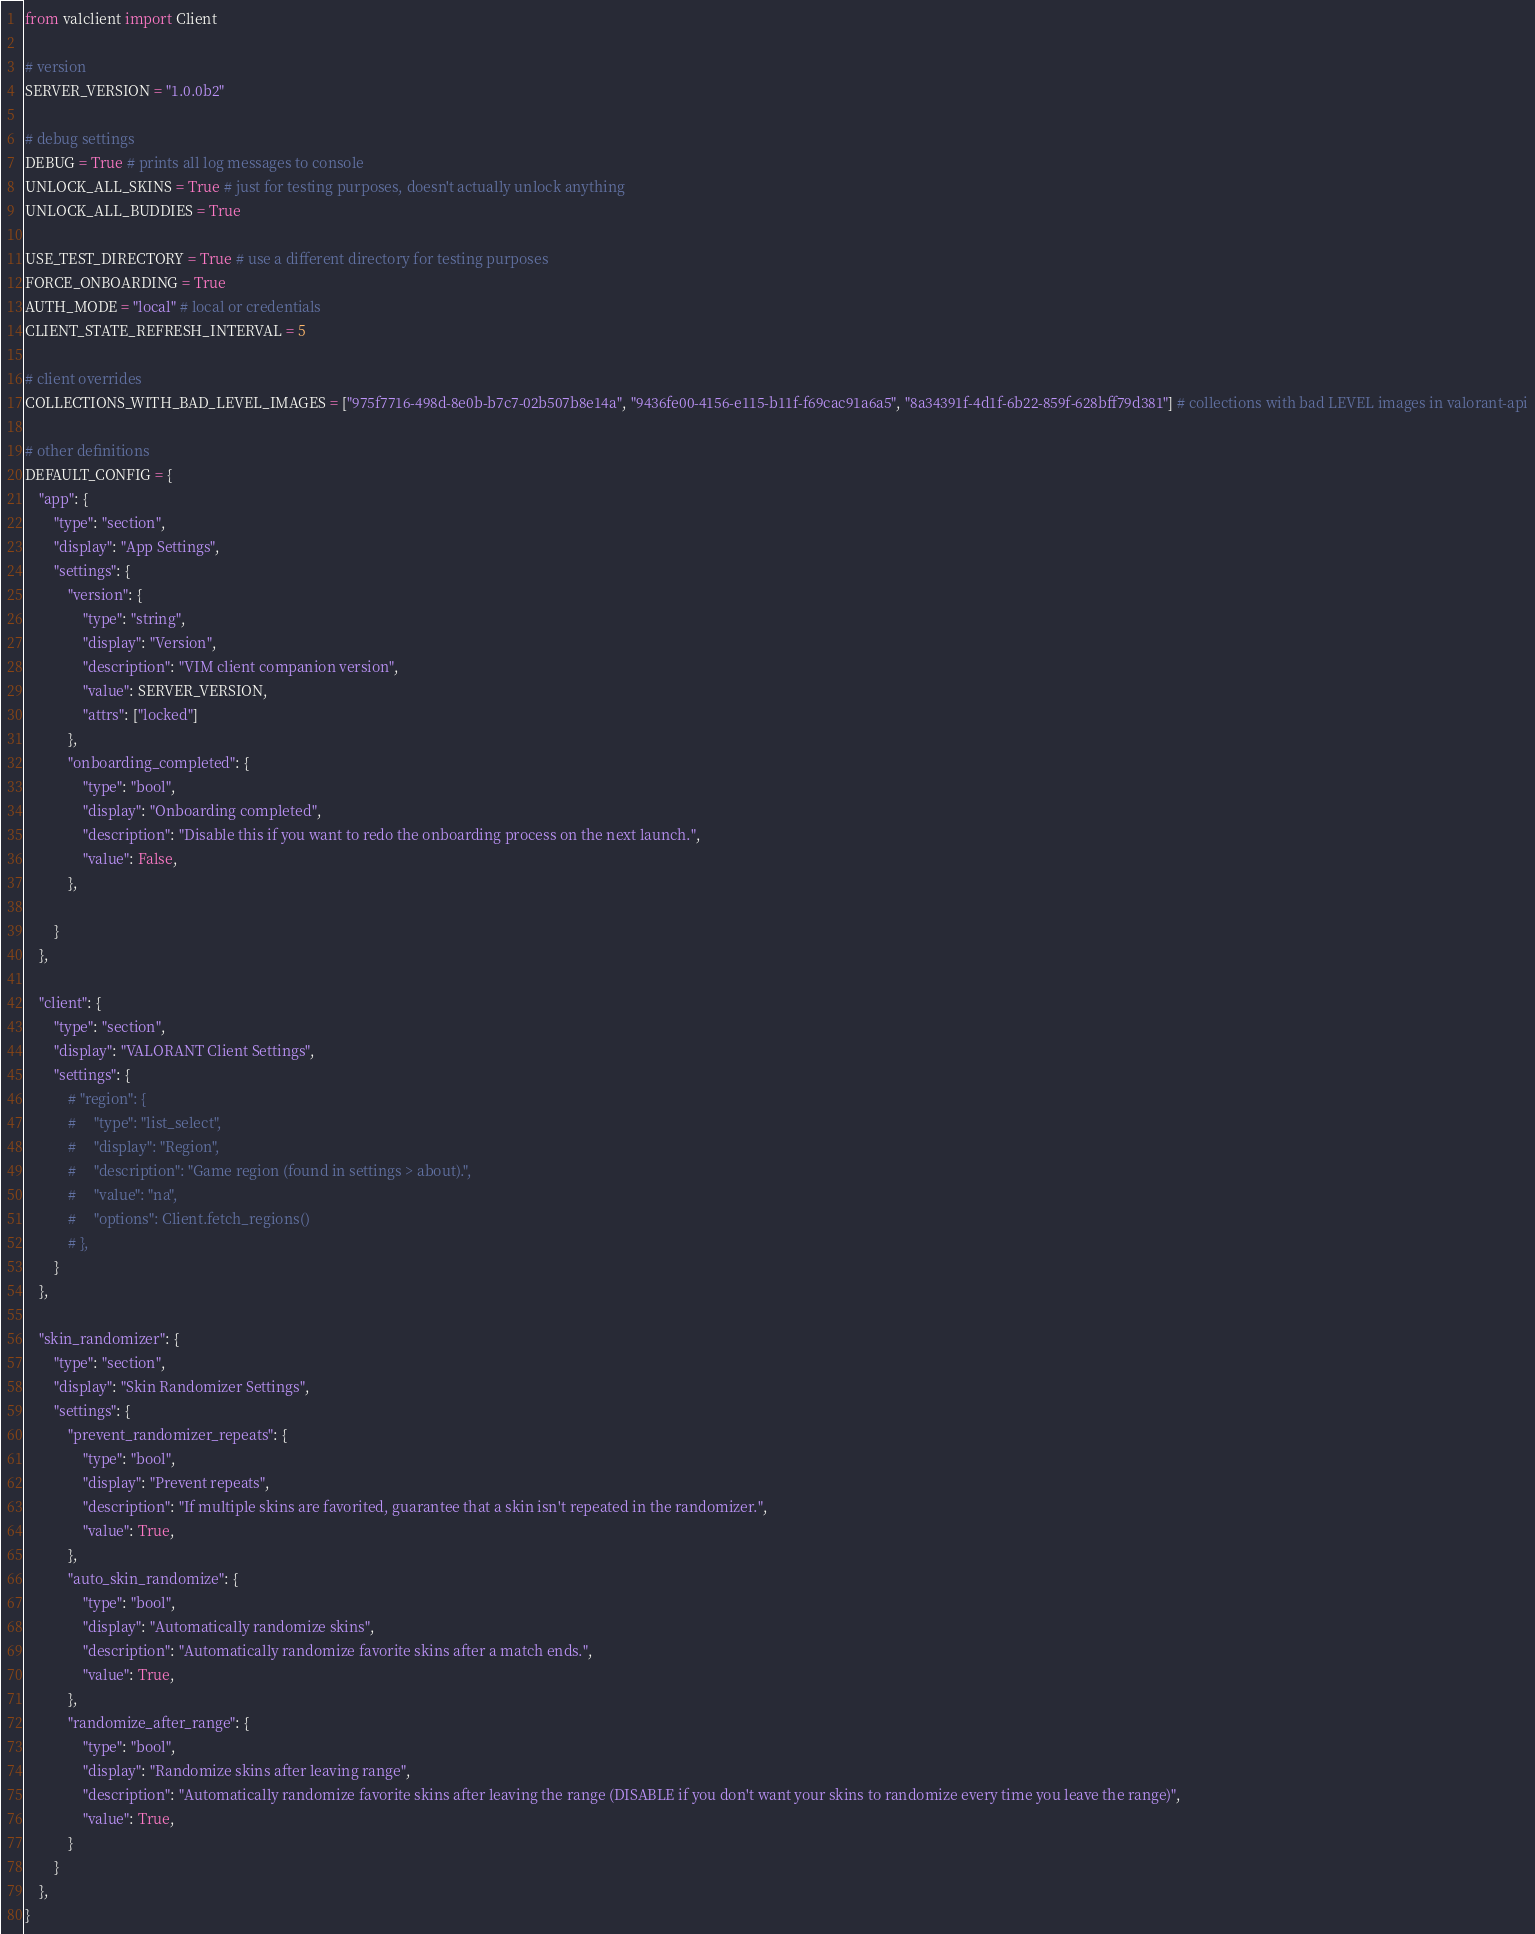Convert code to text. <code><loc_0><loc_0><loc_500><loc_500><_Python_>from valclient import Client

# version
SERVER_VERSION = "1.0.0b2"

# debug settings
DEBUG = True # prints all log messages to console
UNLOCK_ALL_SKINS = True # just for testing purposes, doesn't actually unlock anything
UNLOCK_ALL_BUDDIES = True

USE_TEST_DIRECTORY = True # use a different directory for testing purposes
FORCE_ONBOARDING = True
AUTH_MODE = "local" # local or credentials
CLIENT_STATE_REFRESH_INTERVAL = 5

# client overrides
COLLECTIONS_WITH_BAD_LEVEL_IMAGES = ["975f7716-498d-8e0b-b7c7-02b507b8e14a", "9436fe00-4156-e115-b11f-f69cac91a6a5", "8a34391f-4d1f-6b22-859f-628bff79d381"] # collections with bad LEVEL images in valorant-api

# other definitions
DEFAULT_CONFIG = {
    "app": {
        "type": "section",
        "display": "App Settings",
        "settings": {
            "version": {
                "type": "string",
                "display": "Version",
                "description": "VIM client companion version",
                "value": SERVER_VERSION,
                "attrs": ["locked"]
            },
            "onboarding_completed": {
                "type": "bool",
                "display": "Onboarding completed",
                "description": "Disable this if you want to redo the onboarding process on the next launch.",
                "value": False,
            },
            
        }
    },

    "client": {
        "type": "section",
        "display": "VALORANT Client Settings",
        "settings": {
            # "region": {
            #     "type": "list_select",
            #     "display": "Region",
            #     "description": "Game region (found in settings > about).",
            #     "value": "na",
            #     "options": Client.fetch_regions()
            # },
        }
    },

    "skin_randomizer": {
        "type": "section",
        "display": "Skin Randomizer Settings",
        "settings": {
            "prevent_randomizer_repeats": {
                "type": "bool",
                "display": "Prevent repeats",
                "description": "If multiple skins are favorited, guarantee that a skin isn't repeated in the randomizer.",
                "value": True,
            },
            "auto_skin_randomize": {
                "type": "bool",
                "display": "Automatically randomize skins",
                "description": "Automatically randomize favorite skins after a match ends.",
                "value": True,
            },
            "randomize_after_range": {
                "type": "bool",
                "display": "Randomize skins after leaving range",
                "description": "Automatically randomize favorite skins after leaving the range (DISABLE if you don't want your skins to randomize every time you leave the range)",
                "value": True,
            }
        }
    },
}
</code> 